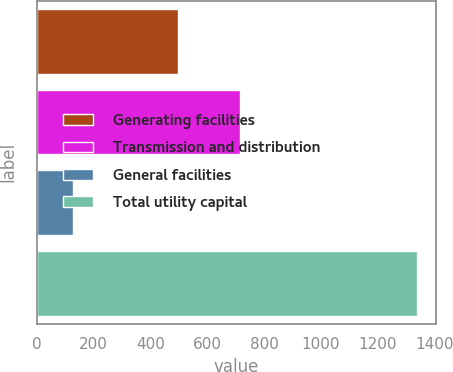<chart> <loc_0><loc_0><loc_500><loc_500><bar_chart><fcel>Generating facilities<fcel>Transmission and distribution<fcel>General facilities<fcel>Total utility capital<nl><fcel>497<fcel>714<fcel>127<fcel>1338<nl></chart> 